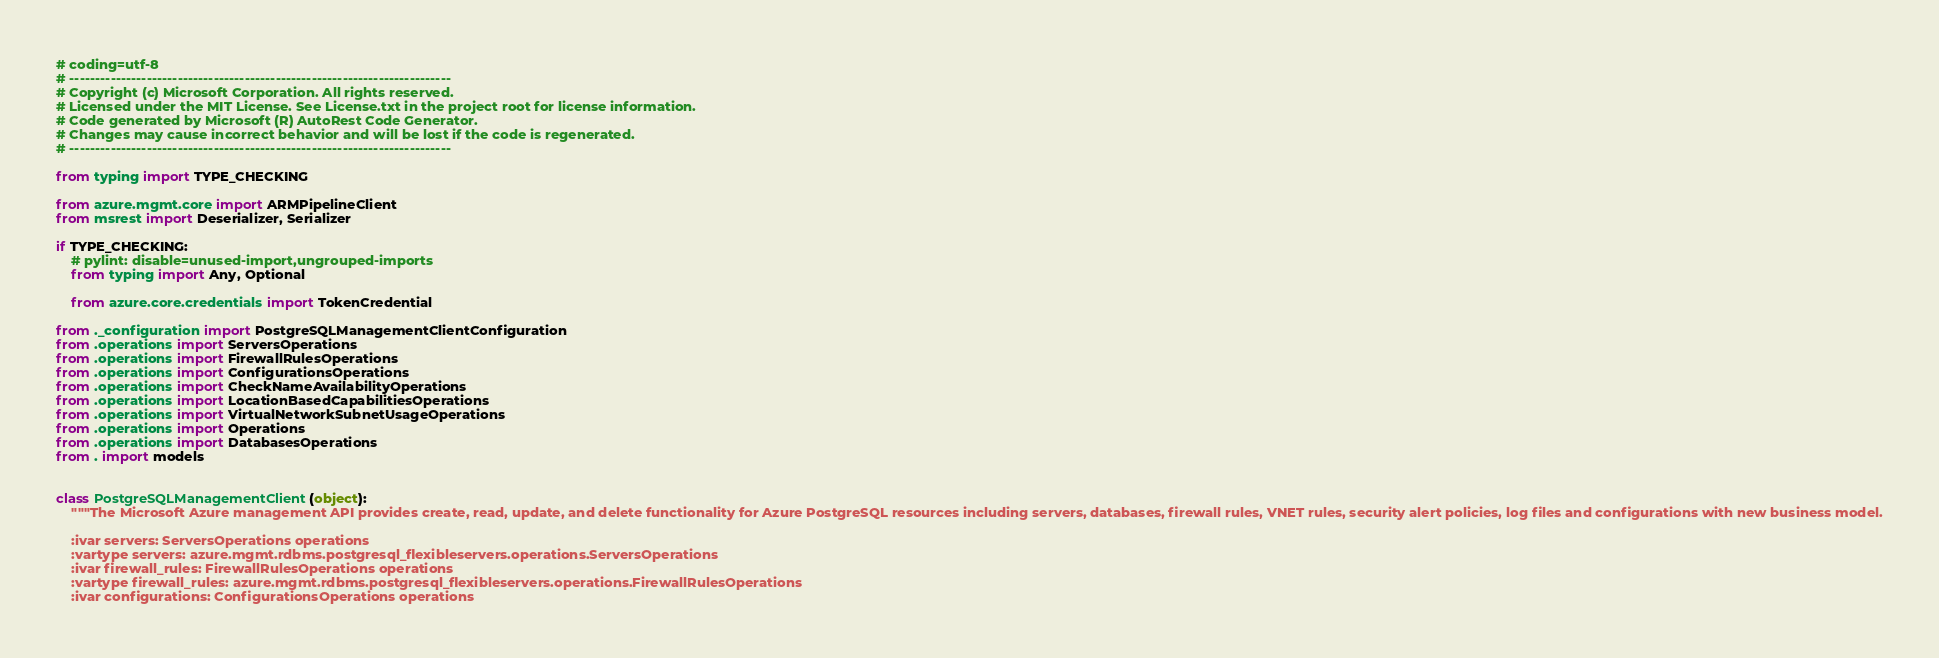<code> <loc_0><loc_0><loc_500><loc_500><_Python_># coding=utf-8
# --------------------------------------------------------------------------
# Copyright (c) Microsoft Corporation. All rights reserved.
# Licensed under the MIT License. See License.txt in the project root for license information.
# Code generated by Microsoft (R) AutoRest Code Generator.
# Changes may cause incorrect behavior and will be lost if the code is regenerated.
# --------------------------------------------------------------------------

from typing import TYPE_CHECKING

from azure.mgmt.core import ARMPipelineClient
from msrest import Deserializer, Serializer

if TYPE_CHECKING:
    # pylint: disable=unused-import,ungrouped-imports
    from typing import Any, Optional

    from azure.core.credentials import TokenCredential

from ._configuration import PostgreSQLManagementClientConfiguration
from .operations import ServersOperations
from .operations import FirewallRulesOperations
from .operations import ConfigurationsOperations
from .operations import CheckNameAvailabilityOperations
from .operations import LocationBasedCapabilitiesOperations
from .operations import VirtualNetworkSubnetUsageOperations
from .operations import Operations
from .operations import DatabasesOperations
from . import models


class PostgreSQLManagementClient(object):
    """The Microsoft Azure management API provides create, read, update, and delete functionality for Azure PostgreSQL resources including servers, databases, firewall rules, VNET rules, security alert policies, log files and configurations with new business model.

    :ivar servers: ServersOperations operations
    :vartype servers: azure.mgmt.rdbms.postgresql_flexibleservers.operations.ServersOperations
    :ivar firewall_rules: FirewallRulesOperations operations
    :vartype firewall_rules: azure.mgmt.rdbms.postgresql_flexibleservers.operations.FirewallRulesOperations
    :ivar configurations: ConfigurationsOperations operations</code> 